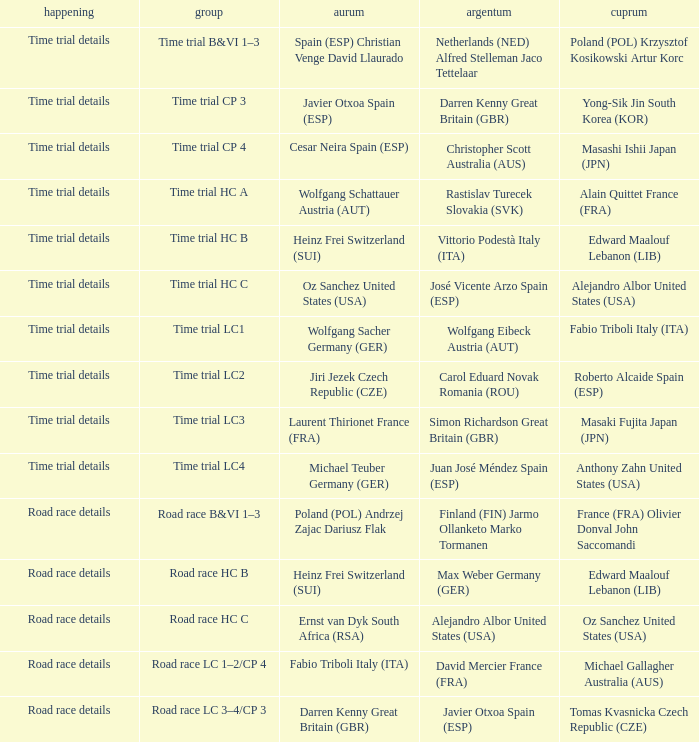Who received gold when the event is road race details and silver is max weber germany (ger)? Heinz Frei Switzerland (SUI). 